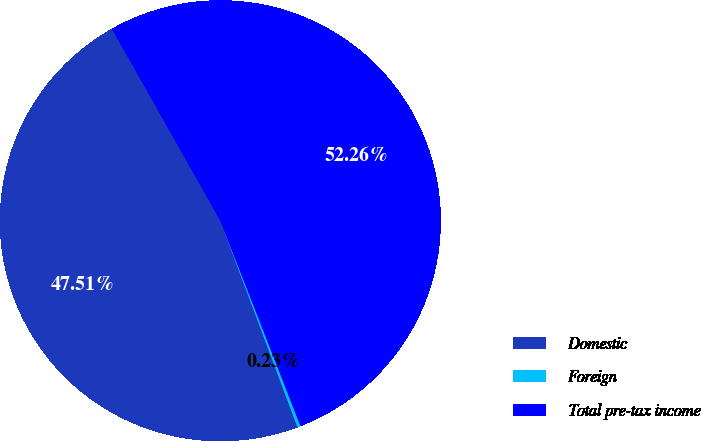<chart> <loc_0><loc_0><loc_500><loc_500><pie_chart><fcel>Domestic<fcel>Foreign<fcel>Total pre-tax income<nl><fcel>47.51%<fcel>0.23%<fcel>52.26%<nl></chart> 